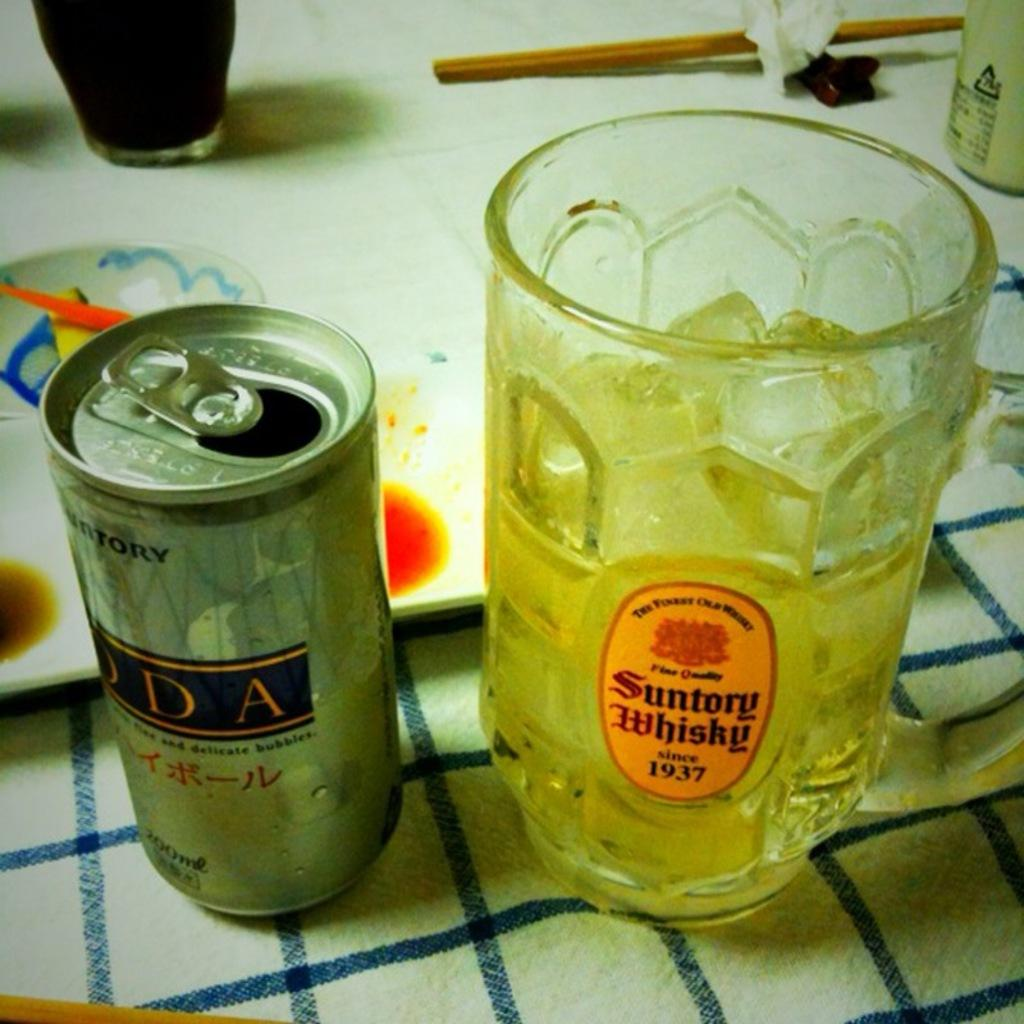<image>
Render a clear and concise summary of the photo. Beer can next to a cup which says "Suntory Whisky" on it. 